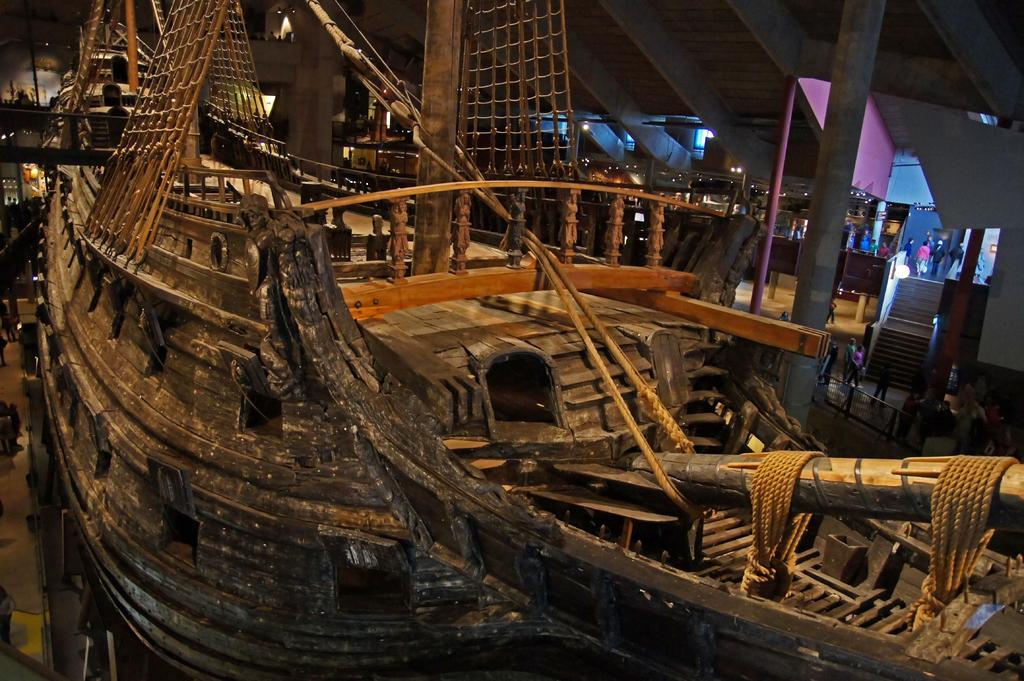What is the main subject in the foreground of the image? There is a wooden ship in the foreground of the image. What can be seen in the background of the image? There are poles, persons walking on the pavement, stairs, and the inside roof of a building visible in the background of the image. What type of wound can be seen on the wooden ship in the image? There is no wound visible on the wooden ship in the image. Where is the lunchroom located in the image? There is no mention of a lunchroom in the image. 